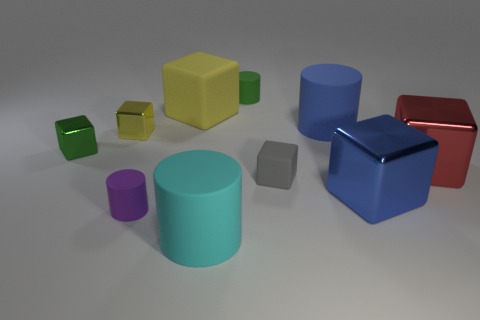Do the green rubber cylinder and the matte cylinder that is left of the cyan rubber object have the same size?
Your response must be concise. Yes. Are there fewer cyan matte objects on the left side of the small purple thing than blue matte things in front of the blue matte thing?
Make the answer very short. No. There is a rubber cube behind the tiny yellow shiny object; what is its size?
Give a very brief answer. Large. Is the green metallic object the same size as the gray object?
Provide a short and direct response. Yes. How many objects are both in front of the blue cube and left of the large yellow matte thing?
Make the answer very short. 1. How many cyan objects are tiny objects or tiny matte cylinders?
Ensure brevity in your answer.  0. What number of metal things are either tiny yellow balls or green cylinders?
Keep it short and to the point. 0. Is there a tiny green shiny block?
Give a very brief answer. Yes. Do the cyan matte object and the green rubber thing have the same shape?
Provide a short and direct response. Yes. There is a large metal block that is to the right of the big metal block that is in front of the red shiny cube; what number of yellow rubber objects are on the left side of it?
Make the answer very short. 1. 